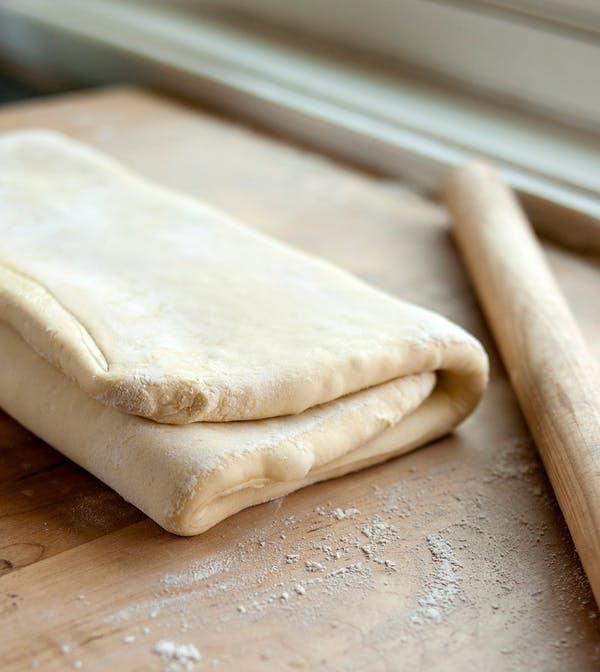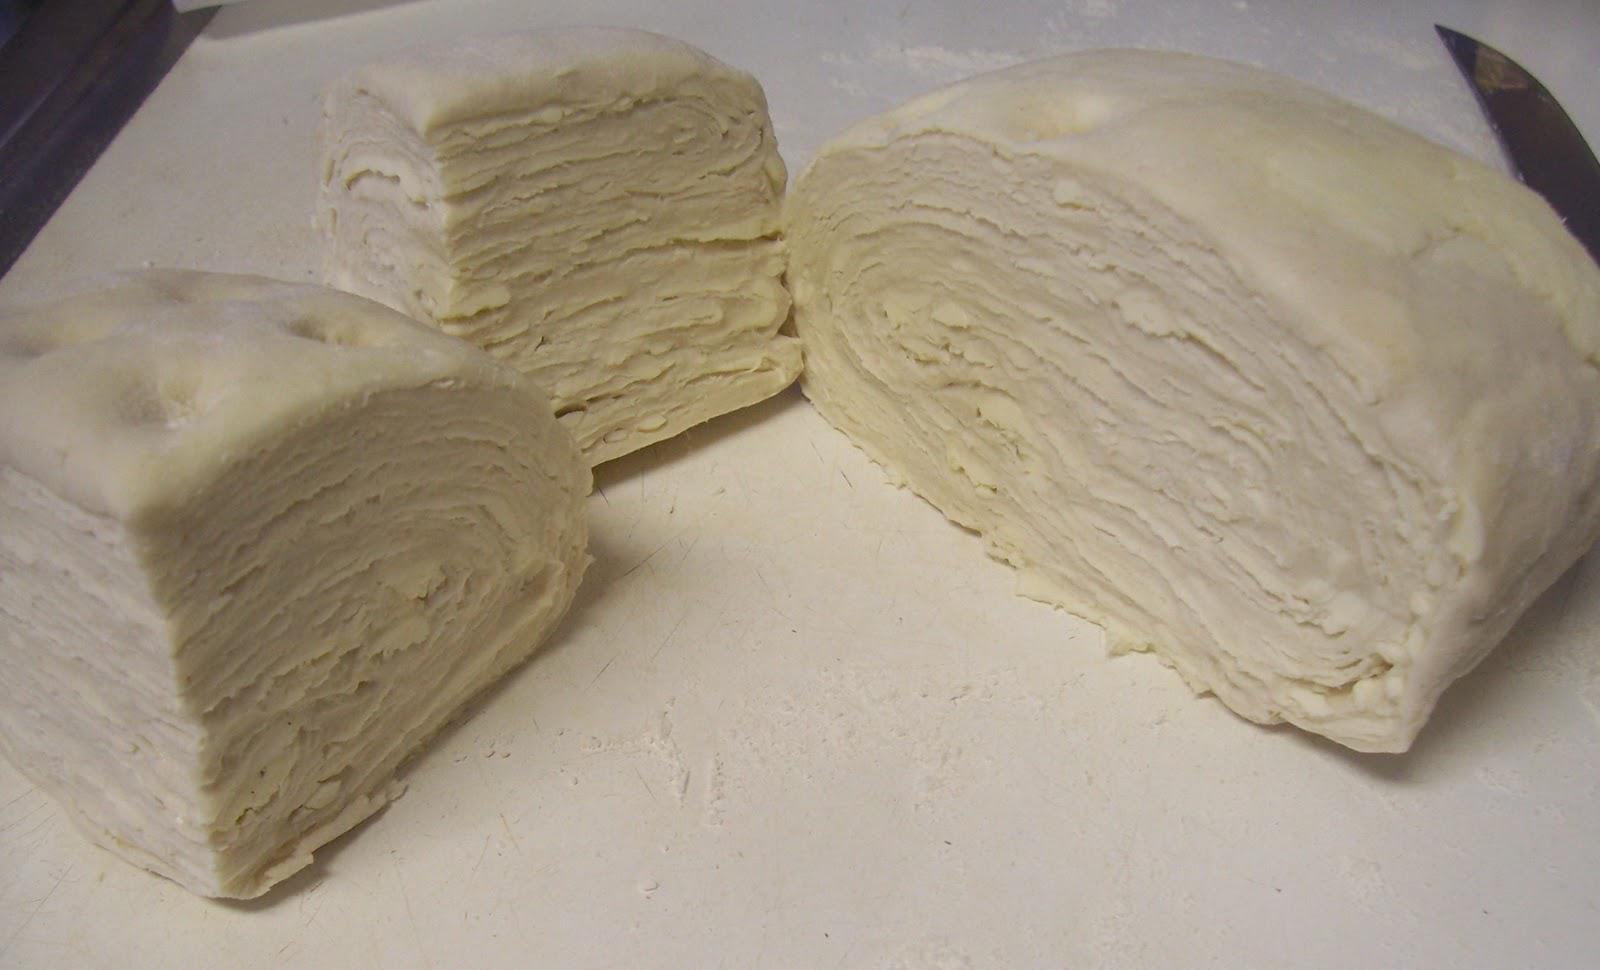The first image is the image on the left, the second image is the image on the right. Considering the images on both sides, is "There is dough in plastic." valid? Answer yes or no. No. The first image is the image on the left, the second image is the image on the right. Evaluate the accuracy of this statement regarding the images: "There are two folded pieces of dough with one in plastic.". Is it true? Answer yes or no. No. 